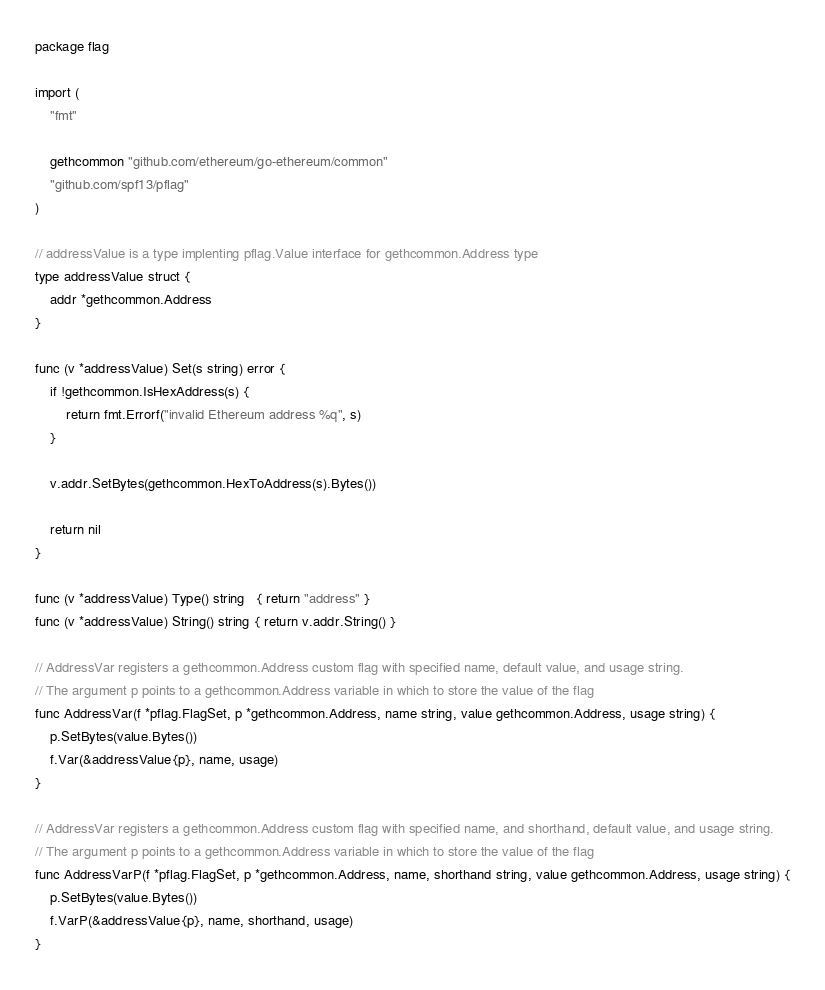<code> <loc_0><loc_0><loc_500><loc_500><_Go_>package flag

import (
	"fmt"

	gethcommon "github.com/ethereum/go-ethereum/common"
	"github.com/spf13/pflag"
)

// addressValue is a type implenting pflag.Value interface for gethcommon.Address type
type addressValue struct {
	addr *gethcommon.Address
}

func (v *addressValue) Set(s string) error {
	if !gethcommon.IsHexAddress(s) {
		return fmt.Errorf("invalid Ethereum address %q", s)
	}

	v.addr.SetBytes(gethcommon.HexToAddress(s).Bytes())

	return nil
}

func (v *addressValue) Type() string   { return "address" }
func (v *addressValue) String() string { return v.addr.String() }

// AddressVar registers a gethcommon.Address custom flag with specified name, default value, and usage string.
// The argument p points to a gethcommon.Address variable in which to store the value of the flag
func AddressVar(f *pflag.FlagSet, p *gethcommon.Address, name string, value gethcommon.Address, usage string) {
	p.SetBytes(value.Bytes())
	f.Var(&addressValue{p}, name, usage)
}

// AddressVar registers a gethcommon.Address custom flag with specified name, and shorthand, default value, and usage string.
// The argument p points to a gethcommon.Address variable in which to store the value of the flag
func AddressVarP(f *pflag.FlagSet, p *gethcommon.Address, name, shorthand string, value gethcommon.Address, usage string) {
	p.SetBytes(value.Bytes())
	f.VarP(&addressValue{p}, name, shorthand, usage)
}
</code> 